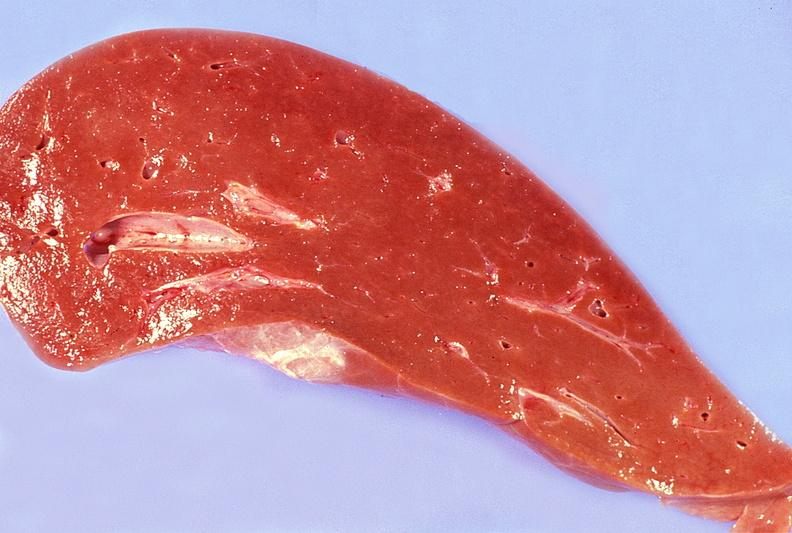does this image show normal liver?
Answer the question using a single word or phrase. Yes 